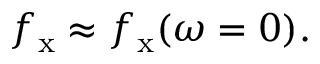<formula> <loc_0><loc_0><loc_500><loc_500>f _ { x } \approx f _ { x } ( \omega = 0 ) .</formula> 